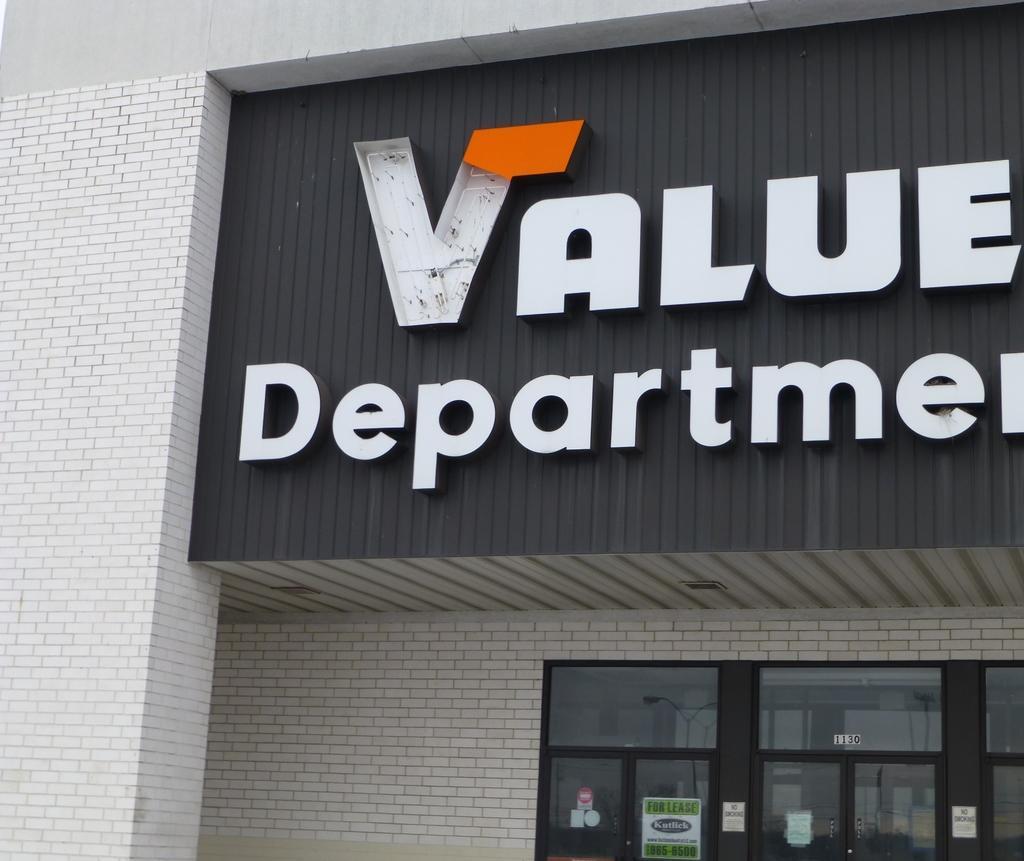Please provide a concise description of this image. In the foreground of this image, there is some text to the building. On the bottom, there are glass doors and few posters on it. 